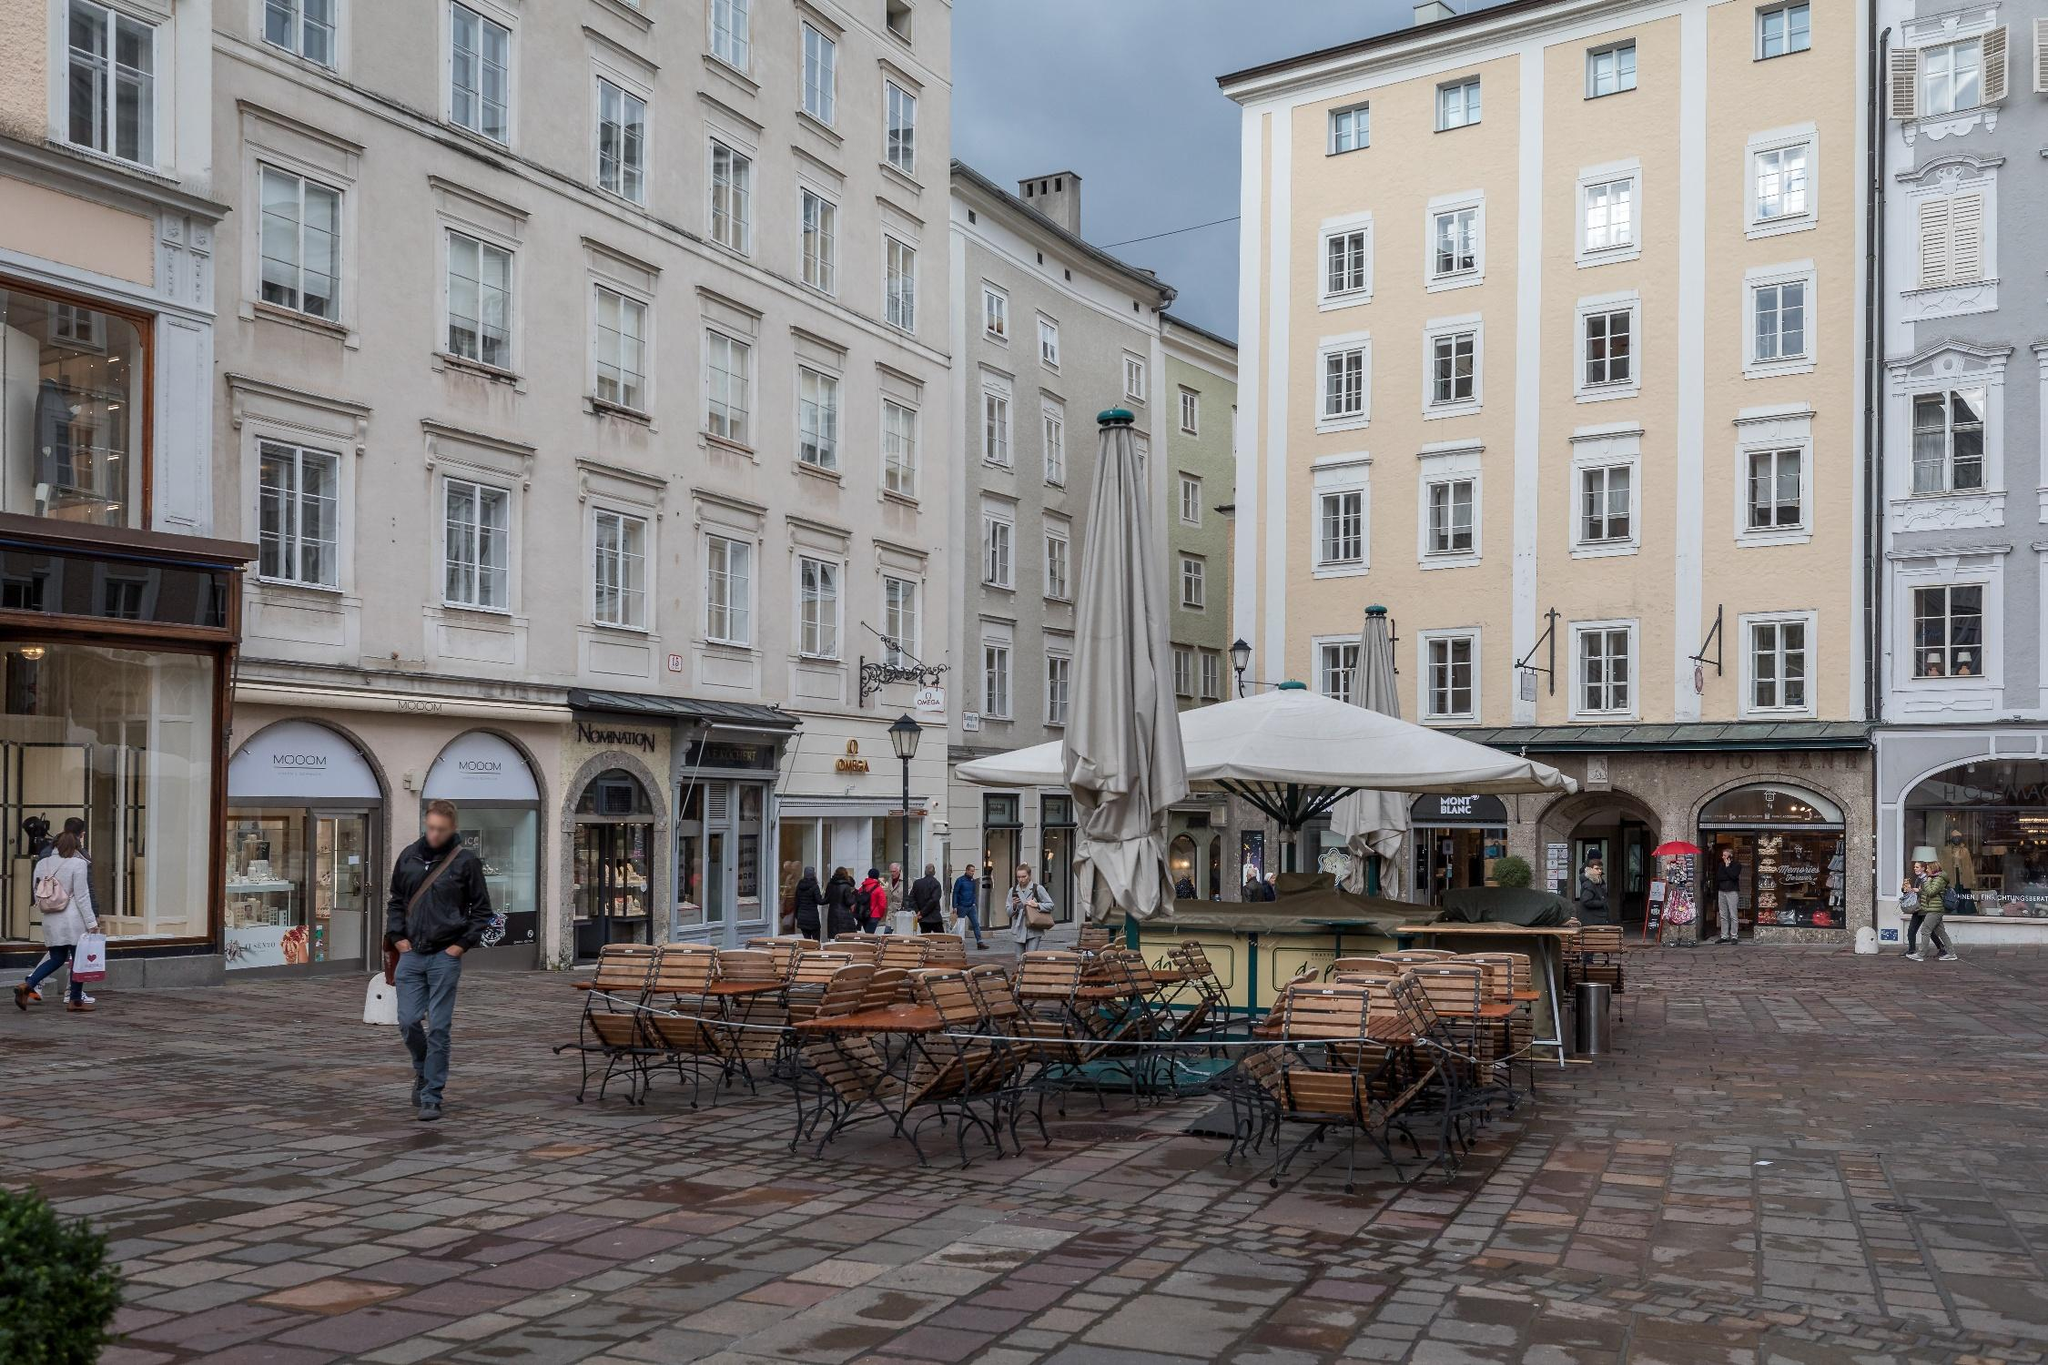If this were a movie set, what genre would it belong to? This street corner would make an ideal set for a romantic drama or a period piece. The charming and historic architecture, along with the inviting café seating, provides a perfect backdrop for scenes of love, heartbreak, and personal growth. Alternatively, the quaint European setting could be the locale for a mystery film, with the cobblestone streets and old buildings harboring secrets and stories waiting to be uncovered. The daily hustle and bustle of the townspeople would add an authentic feel, making the audience feel as though they are truly immersed in the heart of Salzburg. 